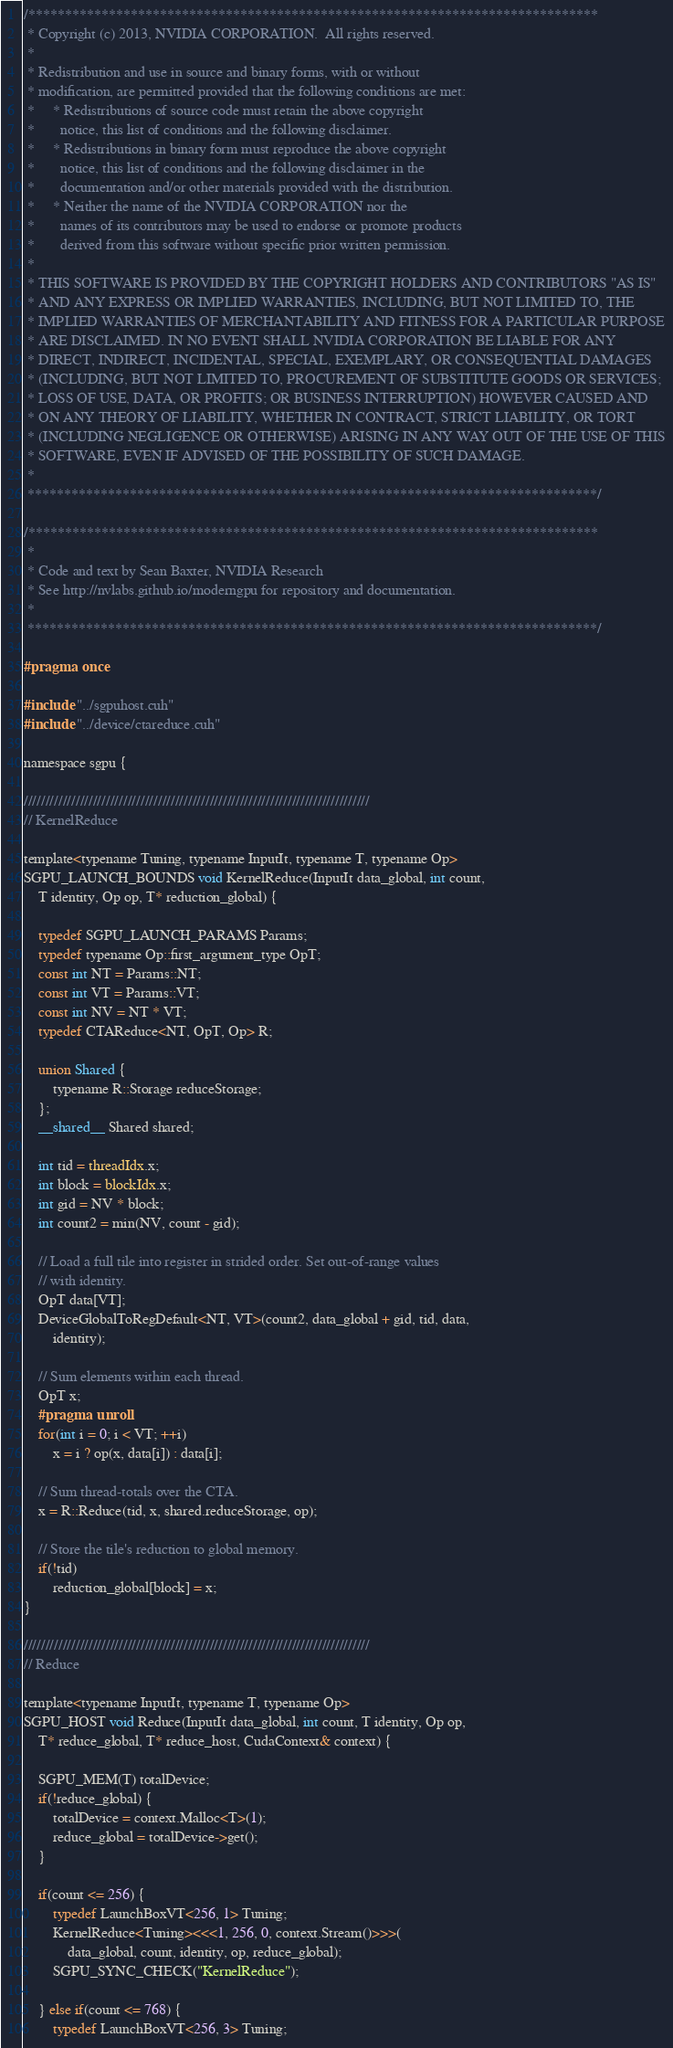<code> <loc_0><loc_0><loc_500><loc_500><_Cuda_>/******************************************************************************
 * Copyright (c) 2013, NVIDIA CORPORATION.  All rights reserved.
 *
 * Redistribution and use in source and binary forms, with or without
 * modification, are permitted provided that the following conditions are met:
 *     * Redistributions of source code must retain the above copyright
 *       notice, this list of conditions and the following disclaimer.
 *     * Redistributions in binary form must reproduce the above copyright
 *       notice, this list of conditions and the following disclaimer in the
 *       documentation and/or other materials provided with the distribution.
 *     * Neither the name of the NVIDIA CORPORATION nor the
 *       names of its contributors may be used to endorse or promote products
 *       derived from this software without specific prior written permission.
 *
 * THIS SOFTWARE IS PROVIDED BY THE COPYRIGHT HOLDERS AND CONTRIBUTORS "AS IS"
 * AND ANY EXPRESS OR IMPLIED WARRANTIES, INCLUDING, BUT NOT LIMITED TO, THE
 * IMPLIED WARRANTIES OF MERCHANTABILITY AND FITNESS FOR A PARTICULAR PURPOSE
 * ARE DISCLAIMED. IN NO EVENT SHALL NVIDIA CORPORATION BE LIABLE FOR ANY
 * DIRECT, INDIRECT, INCIDENTAL, SPECIAL, EXEMPLARY, OR CONSEQUENTIAL DAMAGES
 * (INCLUDING, BUT NOT LIMITED TO, PROCUREMENT OF SUBSTITUTE GOODS OR SERVICES;
 * LOSS OF USE, DATA, OR PROFITS; OR BUSINESS INTERRUPTION) HOWEVER CAUSED AND
 * ON ANY THEORY OF LIABILITY, WHETHER IN CONTRACT, STRICT LIABILITY, OR TORT
 * (INCLUDING NEGLIGENCE OR OTHERWISE) ARISING IN ANY WAY OUT OF THE USE OF THIS
 * SOFTWARE, EVEN IF ADVISED OF THE POSSIBILITY OF SUCH DAMAGE.
 *
 ******************************************************************************/

/******************************************************************************
 *
 * Code and text by Sean Baxter, NVIDIA Research
 * See http://nvlabs.github.io/moderngpu for repository and documentation.
 *
 ******************************************************************************/

#pragma once

#include "../sgpuhost.cuh"
#include "../device/ctareduce.cuh"

namespace sgpu {

////////////////////////////////////////////////////////////////////////////////
// KernelReduce

template<typename Tuning, typename InputIt, typename T, typename Op>
SGPU_LAUNCH_BOUNDS void KernelReduce(InputIt data_global, int count,
	T identity, Op op, T* reduction_global) {

	typedef SGPU_LAUNCH_PARAMS Params;
	typedef typename Op::first_argument_type OpT;
	const int NT = Params::NT;
	const int VT = Params::VT;
	const int NV = NT * VT;
	typedef CTAReduce<NT, OpT, Op> R;

	union Shared {
		typename R::Storage reduceStorage;
	};
	__shared__ Shared shared;

	int tid = threadIdx.x;
	int block = blockIdx.x;
	int gid = NV * block;
	int count2 = min(NV, count - gid);

	// Load a full tile into register in strided order. Set out-of-range values
	// with identity.
	OpT data[VT];
	DeviceGlobalToRegDefault<NT, VT>(count2, data_global + gid, tid, data,
		identity);

	// Sum elements within each thread.
	OpT x;
	#pragma unroll
	for(int i = 0; i < VT; ++i)
		x = i ? op(x, data[i]) : data[i];

	// Sum thread-totals over the CTA.
	x = R::Reduce(tid, x, shared.reduceStorage, op);

	// Store the tile's reduction to global memory.
	if(!tid)
		reduction_global[block] = x;
}

////////////////////////////////////////////////////////////////////////////////
// Reduce

template<typename InputIt, typename T, typename Op>
SGPU_HOST void Reduce(InputIt data_global, int count, T identity, Op op,
	T* reduce_global, T* reduce_host, CudaContext& context) {

	SGPU_MEM(T) totalDevice;
	if(!reduce_global) {
		totalDevice = context.Malloc<T>(1);
		reduce_global = totalDevice->get();
	}

	if(count <= 256) {
		typedef LaunchBoxVT<256, 1> Tuning;
		KernelReduce<Tuning><<<1, 256, 0, context.Stream()>>>(
			data_global, count, identity, op, reduce_global);
		SGPU_SYNC_CHECK("KernelReduce");

	} else if(count <= 768) {
		typedef LaunchBoxVT<256, 3> Tuning;</code> 